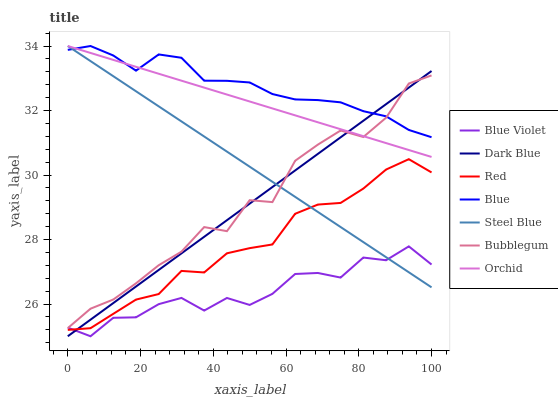Does Blue Violet have the minimum area under the curve?
Answer yes or no. Yes. Does Blue have the maximum area under the curve?
Answer yes or no. Yes. Does Steel Blue have the minimum area under the curve?
Answer yes or no. No. Does Steel Blue have the maximum area under the curve?
Answer yes or no. No. Is Dark Blue the smoothest?
Answer yes or no. Yes. Is Bubblegum the roughest?
Answer yes or no. Yes. Is Steel Blue the smoothest?
Answer yes or no. No. Is Steel Blue the roughest?
Answer yes or no. No. Does Dark Blue have the lowest value?
Answer yes or no. Yes. Does Steel Blue have the lowest value?
Answer yes or no. No. Does Orchid have the highest value?
Answer yes or no. Yes. Does Bubblegum have the highest value?
Answer yes or no. No. Is Red less than Blue?
Answer yes or no. Yes. Is Orchid greater than Blue Violet?
Answer yes or no. Yes. Does Blue Violet intersect Red?
Answer yes or no. Yes. Is Blue Violet less than Red?
Answer yes or no. No. Is Blue Violet greater than Red?
Answer yes or no. No. Does Red intersect Blue?
Answer yes or no. No. 